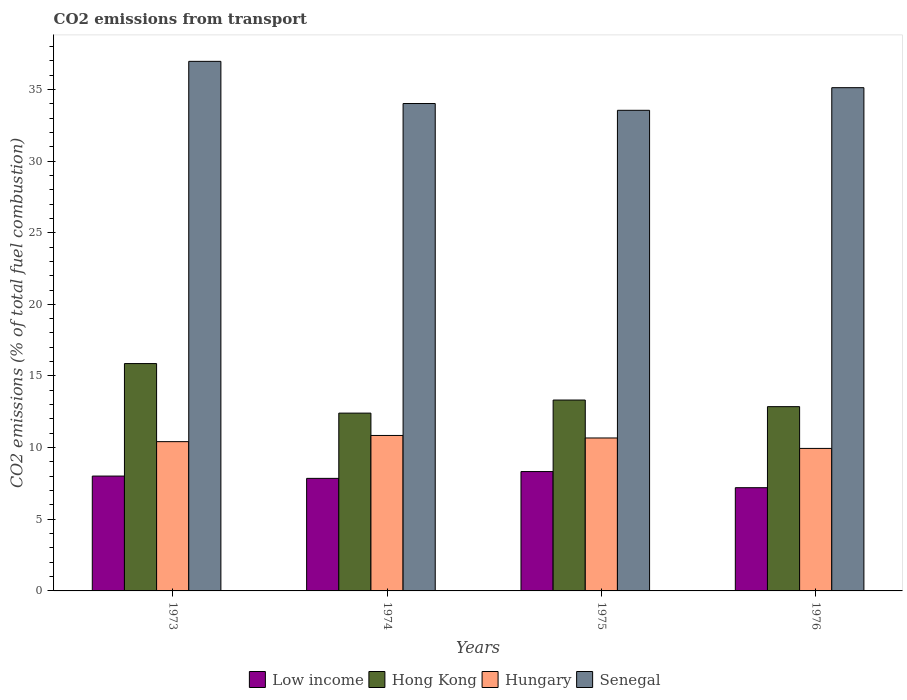How many groups of bars are there?
Your answer should be compact. 4. Are the number of bars per tick equal to the number of legend labels?
Your answer should be very brief. Yes. What is the label of the 4th group of bars from the left?
Your answer should be very brief. 1976. In how many cases, is the number of bars for a given year not equal to the number of legend labels?
Give a very brief answer. 0. What is the total CO2 emitted in Hong Kong in 1974?
Provide a short and direct response. 12.41. Across all years, what is the maximum total CO2 emitted in Hungary?
Offer a very short reply. 10.85. Across all years, what is the minimum total CO2 emitted in Hungary?
Your answer should be compact. 9.94. In which year was the total CO2 emitted in Hungary maximum?
Make the answer very short. 1974. In which year was the total CO2 emitted in Senegal minimum?
Ensure brevity in your answer.  1975. What is the total total CO2 emitted in Low income in the graph?
Keep it short and to the point. 31.4. What is the difference between the total CO2 emitted in Hong Kong in 1975 and that in 1976?
Your response must be concise. 0.46. What is the difference between the total CO2 emitted in Hong Kong in 1975 and the total CO2 emitted in Senegal in 1974?
Your answer should be compact. -20.69. What is the average total CO2 emitted in Senegal per year?
Provide a short and direct response. 34.91. In the year 1975, what is the difference between the total CO2 emitted in Hungary and total CO2 emitted in Senegal?
Ensure brevity in your answer.  -22.87. What is the ratio of the total CO2 emitted in Hungary in 1973 to that in 1976?
Provide a short and direct response. 1.05. Is the total CO2 emitted in Senegal in 1973 less than that in 1974?
Give a very brief answer. No. What is the difference between the highest and the second highest total CO2 emitted in Hong Kong?
Your response must be concise. 2.55. What is the difference between the highest and the lowest total CO2 emitted in Hungary?
Offer a very short reply. 0.9. In how many years, is the total CO2 emitted in Hungary greater than the average total CO2 emitted in Hungary taken over all years?
Ensure brevity in your answer.  2. Is the sum of the total CO2 emitted in Low income in 1974 and 1975 greater than the maximum total CO2 emitted in Hong Kong across all years?
Make the answer very short. Yes. What does the 4th bar from the left in 1973 represents?
Keep it short and to the point. Senegal. What does the 1st bar from the right in 1976 represents?
Offer a terse response. Senegal. Is it the case that in every year, the sum of the total CO2 emitted in Hong Kong and total CO2 emitted in Senegal is greater than the total CO2 emitted in Low income?
Offer a terse response. Yes. Are all the bars in the graph horizontal?
Give a very brief answer. No. How many years are there in the graph?
Provide a succinct answer. 4. Are the values on the major ticks of Y-axis written in scientific E-notation?
Make the answer very short. No. Where does the legend appear in the graph?
Provide a succinct answer. Bottom center. How are the legend labels stacked?
Keep it short and to the point. Horizontal. What is the title of the graph?
Your response must be concise. CO2 emissions from transport. Does "Philippines" appear as one of the legend labels in the graph?
Your response must be concise. No. What is the label or title of the X-axis?
Provide a short and direct response. Years. What is the label or title of the Y-axis?
Offer a terse response. CO2 emissions (% of total fuel combustion). What is the CO2 emissions (% of total fuel combustion) in Low income in 1973?
Provide a short and direct response. 8.01. What is the CO2 emissions (% of total fuel combustion) in Hong Kong in 1973?
Your answer should be compact. 15.87. What is the CO2 emissions (% of total fuel combustion) of Hungary in 1973?
Your answer should be compact. 10.42. What is the CO2 emissions (% of total fuel combustion) in Senegal in 1973?
Your answer should be very brief. 36.96. What is the CO2 emissions (% of total fuel combustion) in Low income in 1974?
Your response must be concise. 7.85. What is the CO2 emissions (% of total fuel combustion) of Hong Kong in 1974?
Your answer should be compact. 12.41. What is the CO2 emissions (% of total fuel combustion) of Hungary in 1974?
Offer a very short reply. 10.85. What is the CO2 emissions (% of total fuel combustion) of Senegal in 1974?
Your response must be concise. 34.01. What is the CO2 emissions (% of total fuel combustion) of Low income in 1975?
Your response must be concise. 8.33. What is the CO2 emissions (% of total fuel combustion) in Hong Kong in 1975?
Offer a very short reply. 13.32. What is the CO2 emissions (% of total fuel combustion) in Hungary in 1975?
Make the answer very short. 10.67. What is the CO2 emissions (% of total fuel combustion) of Senegal in 1975?
Offer a very short reply. 33.54. What is the CO2 emissions (% of total fuel combustion) in Low income in 1976?
Your answer should be compact. 7.2. What is the CO2 emissions (% of total fuel combustion) in Hong Kong in 1976?
Keep it short and to the point. 12.86. What is the CO2 emissions (% of total fuel combustion) in Hungary in 1976?
Provide a short and direct response. 9.94. What is the CO2 emissions (% of total fuel combustion) in Senegal in 1976?
Your answer should be very brief. 35.12. Across all years, what is the maximum CO2 emissions (% of total fuel combustion) in Low income?
Provide a succinct answer. 8.33. Across all years, what is the maximum CO2 emissions (% of total fuel combustion) in Hong Kong?
Give a very brief answer. 15.87. Across all years, what is the maximum CO2 emissions (% of total fuel combustion) in Hungary?
Keep it short and to the point. 10.85. Across all years, what is the maximum CO2 emissions (% of total fuel combustion) of Senegal?
Give a very brief answer. 36.96. Across all years, what is the minimum CO2 emissions (% of total fuel combustion) of Low income?
Give a very brief answer. 7.2. Across all years, what is the minimum CO2 emissions (% of total fuel combustion) of Hong Kong?
Make the answer very short. 12.41. Across all years, what is the minimum CO2 emissions (% of total fuel combustion) in Hungary?
Your answer should be compact. 9.94. Across all years, what is the minimum CO2 emissions (% of total fuel combustion) of Senegal?
Your response must be concise. 33.54. What is the total CO2 emissions (% of total fuel combustion) of Low income in the graph?
Offer a very short reply. 31.4. What is the total CO2 emissions (% of total fuel combustion) in Hong Kong in the graph?
Ensure brevity in your answer.  54.46. What is the total CO2 emissions (% of total fuel combustion) of Hungary in the graph?
Ensure brevity in your answer.  41.88. What is the total CO2 emissions (% of total fuel combustion) of Senegal in the graph?
Ensure brevity in your answer.  139.63. What is the difference between the CO2 emissions (% of total fuel combustion) in Low income in 1973 and that in 1974?
Make the answer very short. 0.16. What is the difference between the CO2 emissions (% of total fuel combustion) of Hong Kong in 1973 and that in 1974?
Your answer should be compact. 3.46. What is the difference between the CO2 emissions (% of total fuel combustion) in Hungary in 1973 and that in 1974?
Make the answer very short. -0.43. What is the difference between the CO2 emissions (% of total fuel combustion) of Senegal in 1973 and that in 1974?
Keep it short and to the point. 2.94. What is the difference between the CO2 emissions (% of total fuel combustion) in Low income in 1973 and that in 1975?
Ensure brevity in your answer.  -0.31. What is the difference between the CO2 emissions (% of total fuel combustion) in Hong Kong in 1973 and that in 1975?
Provide a succinct answer. 2.55. What is the difference between the CO2 emissions (% of total fuel combustion) of Hungary in 1973 and that in 1975?
Your answer should be very brief. -0.26. What is the difference between the CO2 emissions (% of total fuel combustion) of Senegal in 1973 and that in 1975?
Ensure brevity in your answer.  3.42. What is the difference between the CO2 emissions (% of total fuel combustion) in Low income in 1973 and that in 1976?
Provide a succinct answer. 0.81. What is the difference between the CO2 emissions (% of total fuel combustion) of Hong Kong in 1973 and that in 1976?
Give a very brief answer. 3.01. What is the difference between the CO2 emissions (% of total fuel combustion) in Hungary in 1973 and that in 1976?
Make the answer very short. 0.47. What is the difference between the CO2 emissions (% of total fuel combustion) in Senegal in 1973 and that in 1976?
Give a very brief answer. 1.84. What is the difference between the CO2 emissions (% of total fuel combustion) of Low income in 1974 and that in 1975?
Your answer should be very brief. -0.47. What is the difference between the CO2 emissions (% of total fuel combustion) in Hong Kong in 1974 and that in 1975?
Give a very brief answer. -0.91. What is the difference between the CO2 emissions (% of total fuel combustion) of Hungary in 1974 and that in 1975?
Your answer should be compact. 0.18. What is the difference between the CO2 emissions (% of total fuel combustion) in Senegal in 1974 and that in 1975?
Keep it short and to the point. 0.47. What is the difference between the CO2 emissions (% of total fuel combustion) in Low income in 1974 and that in 1976?
Provide a short and direct response. 0.65. What is the difference between the CO2 emissions (% of total fuel combustion) in Hong Kong in 1974 and that in 1976?
Keep it short and to the point. -0.45. What is the difference between the CO2 emissions (% of total fuel combustion) of Hungary in 1974 and that in 1976?
Give a very brief answer. 0.9. What is the difference between the CO2 emissions (% of total fuel combustion) in Senegal in 1974 and that in 1976?
Offer a very short reply. -1.11. What is the difference between the CO2 emissions (% of total fuel combustion) of Low income in 1975 and that in 1976?
Your answer should be compact. 1.13. What is the difference between the CO2 emissions (% of total fuel combustion) of Hong Kong in 1975 and that in 1976?
Your response must be concise. 0.46. What is the difference between the CO2 emissions (% of total fuel combustion) of Hungary in 1975 and that in 1976?
Keep it short and to the point. 0.73. What is the difference between the CO2 emissions (% of total fuel combustion) of Senegal in 1975 and that in 1976?
Your answer should be very brief. -1.58. What is the difference between the CO2 emissions (% of total fuel combustion) of Low income in 1973 and the CO2 emissions (% of total fuel combustion) of Hong Kong in 1974?
Your response must be concise. -4.39. What is the difference between the CO2 emissions (% of total fuel combustion) in Low income in 1973 and the CO2 emissions (% of total fuel combustion) in Hungary in 1974?
Your answer should be very brief. -2.83. What is the difference between the CO2 emissions (% of total fuel combustion) of Low income in 1973 and the CO2 emissions (% of total fuel combustion) of Senegal in 1974?
Offer a terse response. -26. What is the difference between the CO2 emissions (% of total fuel combustion) in Hong Kong in 1973 and the CO2 emissions (% of total fuel combustion) in Hungary in 1974?
Offer a terse response. 5.02. What is the difference between the CO2 emissions (% of total fuel combustion) in Hong Kong in 1973 and the CO2 emissions (% of total fuel combustion) in Senegal in 1974?
Your response must be concise. -18.15. What is the difference between the CO2 emissions (% of total fuel combustion) of Hungary in 1973 and the CO2 emissions (% of total fuel combustion) of Senegal in 1974?
Keep it short and to the point. -23.6. What is the difference between the CO2 emissions (% of total fuel combustion) in Low income in 1973 and the CO2 emissions (% of total fuel combustion) in Hong Kong in 1975?
Offer a very short reply. -5.31. What is the difference between the CO2 emissions (% of total fuel combustion) of Low income in 1973 and the CO2 emissions (% of total fuel combustion) of Hungary in 1975?
Your response must be concise. -2.66. What is the difference between the CO2 emissions (% of total fuel combustion) of Low income in 1973 and the CO2 emissions (% of total fuel combustion) of Senegal in 1975?
Your answer should be compact. -25.53. What is the difference between the CO2 emissions (% of total fuel combustion) in Hong Kong in 1973 and the CO2 emissions (% of total fuel combustion) in Hungary in 1975?
Provide a succinct answer. 5.19. What is the difference between the CO2 emissions (% of total fuel combustion) of Hong Kong in 1973 and the CO2 emissions (% of total fuel combustion) of Senegal in 1975?
Your response must be concise. -17.67. What is the difference between the CO2 emissions (% of total fuel combustion) in Hungary in 1973 and the CO2 emissions (% of total fuel combustion) in Senegal in 1975?
Ensure brevity in your answer.  -23.12. What is the difference between the CO2 emissions (% of total fuel combustion) in Low income in 1973 and the CO2 emissions (% of total fuel combustion) in Hong Kong in 1976?
Make the answer very short. -4.84. What is the difference between the CO2 emissions (% of total fuel combustion) of Low income in 1973 and the CO2 emissions (% of total fuel combustion) of Hungary in 1976?
Your answer should be compact. -1.93. What is the difference between the CO2 emissions (% of total fuel combustion) in Low income in 1973 and the CO2 emissions (% of total fuel combustion) in Senegal in 1976?
Your answer should be compact. -27.1. What is the difference between the CO2 emissions (% of total fuel combustion) of Hong Kong in 1973 and the CO2 emissions (% of total fuel combustion) of Hungary in 1976?
Give a very brief answer. 5.92. What is the difference between the CO2 emissions (% of total fuel combustion) in Hong Kong in 1973 and the CO2 emissions (% of total fuel combustion) in Senegal in 1976?
Offer a very short reply. -19.25. What is the difference between the CO2 emissions (% of total fuel combustion) in Hungary in 1973 and the CO2 emissions (% of total fuel combustion) in Senegal in 1976?
Your response must be concise. -24.7. What is the difference between the CO2 emissions (% of total fuel combustion) in Low income in 1974 and the CO2 emissions (% of total fuel combustion) in Hong Kong in 1975?
Make the answer very short. -5.47. What is the difference between the CO2 emissions (% of total fuel combustion) in Low income in 1974 and the CO2 emissions (% of total fuel combustion) in Hungary in 1975?
Make the answer very short. -2.82. What is the difference between the CO2 emissions (% of total fuel combustion) in Low income in 1974 and the CO2 emissions (% of total fuel combustion) in Senegal in 1975?
Your response must be concise. -25.69. What is the difference between the CO2 emissions (% of total fuel combustion) in Hong Kong in 1974 and the CO2 emissions (% of total fuel combustion) in Hungary in 1975?
Your answer should be very brief. 1.74. What is the difference between the CO2 emissions (% of total fuel combustion) of Hong Kong in 1974 and the CO2 emissions (% of total fuel combustion) of Senegal in 1975?
Offer a terse response. -21.13. What is the difference between the CO2 emissions (% of total fuel combustion) of Hungary in 1974 and the CO2 emissions (% of total fuel combustion) of Senegal in 1975?
Give a very brief answer. -22.69. What is the difference between the CO2 emissions (% of total fuel combustion) of Low income in 1974 and the CO2 emissions (% of total fuel combustion) of Hong Kong in 1976?
Your answer should be very brief. -5. What is the difference between the CO2 emissions (% of total fuel combustion) of Low income in 1974 and the CO2 emissions (% of total fuel combustion) of Hungary in 1976?
Ensure brevity in your answer.  -2.09. What is the difference between the CO2 emissions (% of total fuel combustion) in Low income in 1974 and the CO2 emissions (% of total fuel combustion) in Senegal in 1976?
Offer a very short reply. -27.26. What is the difference between the CO2 emissions (% of total fuel combustion) of Hong Kong in 1974 and the CO2 emissions (% of total fuel combustion) of Hungary in 1976?
Your answer should be very brief. 2.46. What is the difference between the CO2 emissions (% of total fuel combustion) of Hong Kong in 1974 and the CO2 emissions (% of total fuel combustion) of Senegal in 1976?
Make the answer very short. -22.71. What is the difference between the CO2 emissions (% of total fuel combustion) of Hungary in 1974 and the CO2 emissions (% of total fuel combustion) of Senegal in 1976?
Provide a succinct answer. -24.27. What is the difference between the CO2 emissions (% of total fuel combustion) in Low income in 1975 and the CO2 emissions (% of total fuel combustion) in Hong Kong in 1976?
Ensure brevity in your answer.  -4.53. What is the difference between the CO2 emissions (% of total fuel combustion) in Low income in 1975 and the CO2 emissions (% of total fuel combustion) in Hungary in 1976?
Provide a short and direct response. -1.62. What is the difference between the CO2 emissions (% of total fuel combustion) in Low income in 1975 and the CO2 emissions (% of total fuel combustion) in Senegal in 1976?
Provide a succinct answer. -26.79. What is the difference between the CO2 emissions (% of total fuel combustion) of Hong Kong in 1975 and the CO2 emissions (% of total fuel combustion) of Hungary in 1976?
Your answer should be compact. 3.38. What is the difference between the CO2 emissions (% of total fuel combustion) of Hong Kong in 1975 and the CO2 emissions (% of total fuel combustion) of Senegal in 1976?
Offer a very short reply. -21.8. What is the difference between the CO2 emissions (% of total fuel combustion) in Hungary in 1975 and the CO2 emissions (% of total fuel combustion) in Senegal in 1976?
Ensure brevity in your answer.  -24.45. What is the average CO2 emissions (% of total fuel combustion) of Low income per year?
Offer a terse response. 7.85. What is the average CO2 emissions (% of total fuel combustion) in Hong Kong per year?
Your answer should be compact. 13.61. What is the average CO2 emissions (% of total fuel combustion) in Hungary per year?
Your answer should be compact. 10.47. What is the average CO2 emissions (% of total fuel combustion) of Senegal per year?
Make the answer very short. 34.91. In the year 1973, what is the difference between the CO2 emissions (% of total fuel combustion) in Low income and CO2 emissions (% of total fuel combustion) in Hong Kong?
Ensure brevity in your answer.  -7.85. In the year 1973, what is the difference between the CO2 emissions (% of total fuel combustion) in Low income and CO2 emissions (% of total fuel combustion) in Hungary?
Make the answer very short. -2.4. In the year 1973, what is the difference between the CO2 emissions (% of total fuel combustion) in Low income and CO2 emissions (% of total fuel combustion) in Senegal?
Provide a short and direct response. -28.94. In the year 1973, what is the difference between the CO2 emissions (% of total fuel combustion) in Hong Kong and CO2 emissions (% of total fuel combustion) in Hungary?
Give a very brief answer. 5.45. In the year 1973, what is the difference between the CO2 emissions (% of total fuel combustion) in Hong Kong and CO2 emissions (% of total fuel combustion) in Senegal?
Your answer should be compact. -21.09. In the year 1973, what is the difference between the CO2 emissions (% of total fuel combustion) of Hungary and CO2 emissions (% of total fuel combustion) of Senegal?
Ensure brevity in your answer.  -26.54. In the year 1974, what is the difference between the CO2 emissions (% of total fuel combustion) of Low income and CO2 emissions (% of total fuel combustion) of Hong Kong?
Make the answer very short. -4.55. In the year 1974, what is the difference between the CO2 emissions (% of total fuel combustion) in Low income and CO2 emissions (% of total fuel combustion) in Hungary?
Offer a terse response. -2.99. In the year 1974, what is the difference between the CO2 emissions (% of total fuel combustion) of Low income and CO2 emissions (% of total fuel combustion) of Senegal?
Your answer should be very brief. -26.16. In the year 1974, what is the difference between the CO2 emissions (% of total fuel combustion) in Hong Kong and CO2 emissions (% of total fuel combustion) in Hungary?
Make the answer very short. 1.56. In the year 1974, what is the difference between the CO2 emissions (% of total fuel combustion) of Hong Kong and CO2 emissions (% of total fuel combustion) of Senegal?
Your answer should be compact. -21.6. In the year 1974, what is the difference between the CO2 emissions (% of total fuel combustion) in Hungary and CO2 emissions (% of total fuel combustion) in Senegal?
Provide a succinct answer. -23.16. In the year 1975, what is the difference between the CO2 emissions (% of total fuel combustion) in Low income and CO2 emissions (% of total fuel combustion) in Hong Kong?
Offer a terse response. -4.99. In the year 1975, what is the difference between the CO2 emissions (% of total fuel combustion) in Low income and CO2 emissions (% of total fuel combustion) in Hungary?
Offer a very short reply. -2.34. In the year 1975, what is the difference between the CO2 emissions (% of total fuel combustion) of Low income and CO2 emissions (% of total fuel combustion) of Senegal?
Make the answer very short. -25.21. In the year 1975, what is the difference between the CO2 emissions (% of total fuel combustion) in Hong Kong and CO2 emissions (% of total fuel combustion) in Hungary?
Make the answer very short. 2.65. In the year 1975, what is the difference between the CO2 emissions (% of total fuel combustion) of Hong Kong and CO2 emissions (% of total fuel combustion) of Senegal?
Provide a short and direct response. -20.22. In the year 1975, what is the difference between the CO2 emissions (% of total fuel combustion) of Hungary and CO2 emissions (% of total fuel combustion) of Senegal?
Offer a very short reply. -22.87. In the year 1976, what is the difference between the CO2 emissions (% of total fuel combustion) in Low income and CO2 emissions (% of total fuel combustion) in Hong Kong?
Offer a very short reply. -5.66. In the year 1976, what is the difference between the CO2 emissions (% of total fuel combustion) in Low income and CO2 emissions (% of total fuel combustion) in Hungary?
Keep it short and to the point. -2.74. In the year 1976, what is the difference between the CO2 emissions (% of total fuel combustion) in Low income and CO2 emissions (% of total fuel combustion) in Senegal?
Your response must be concise. -27.92. In the year 1976, what is the difference between the CO2 emissions (% of total fuel combustion) in Hong Kong and CO2 emissions (% of total fuel combustion) in Hungary?
Make the answer very short. 2.91. In the year 1976, what is the difference between the CO2 emissions (% of total fuel combustion) of Hong Kong and CO2 emissions (% of total fuel combustion) of Senegal?
Offer a terse response. -22.26. In the year 1976, what is the difference between the CO2 emissions (% of total fuel combustion) in Hungary and CO2 emissions (% of total fuel combustion) in Senegal?
Your response must be concise. -25.17. What is the ratio of the CO2 emissions (% of total fuel combustion) in Low income in 1973 to that in 1974?
Offer a very short reply. 1.02. What is the ratio of the CO2 emissions (% of total fuel combustion) of Hong Kong in 1973 to that in 1974?
Offer a very short reply. 1.28. What is the ratio of the CO2 emissions (% of total fuel combustion) of Hungary in 1973 to that in 1974?
Ensure brevity in your answer.  0.96. What is the ratio of the CO2 emissions (% of total fuel combustion) in Senegal in 1973 to that in 1974?
Offer a very short reply. 1.09. What is the ratio of the CO2 emissions (% of total fuel combustion) of Low income in 1973 to that in 1975?
Your answer should be very brief. 0.96. What is the ratio of the CO2 emissions (% of total fuel combustion) in Hong Kong in 1973 to that in 1975?
Your answer should be compact. 1.19. What is the ratio of the CO2 emissions (% of total fuel combustion) in Hungary in 1973 to that in 1975?
Your response must be concise. 0.98. What is the ratio of the CO2 emissions (% of total fuel combustion) of Senegal in 1973 to that in 1975?
Your answer should be compact. 1.1. What is the ratio of the CO2 emissions (% of total fuel combustion) of Low income in 1973 to that in 1976?
Make the answer very short. 1.11. What is the ratio of the CO2 emissions (% of total fuel combustion) of Hong Kong in 1973 to that in 1976?
Offer a terse response. 1.23. What is the ratio of the CO2 emissions (% of total fuel combustion) in Hungary in 1973 to that in 1976?
Give a very brief answer. 1.05. What is the ratio of the CO2 emissions (% of total fuel combustion) in Senegal in 1973 to that in 1976?
Provide a succinct answer. 1.05. What is the ratio of the CO2 emissions (% of total fuel combustion) in Low income in 1974 to that in 1975?
Keep it short and to the point. 0.94. What is the ratio of the CO2 emissions (% of total fuel combustion) of Hong Kong in 1974 to that in 1975?
Your answer should be compact. 0.93. What is the ratio of the CO2 emissions (% of total fuel combustion) in Hungary in 1974 to that in 1975?
Give a very brief answer. 1.02. What is the ratio of the CO2 emissions (% of total fuel combustion) in Senegal in 1974 to that in 1975?
Your answer should be very brief. 1.01. What is the ratio of the CO2 emissions (% of total fuel combustion) of Low income in 1974 to that in 1976?
Provide a succinct answer. 1.09. What is the ratio of the CO2 emissions (% of total fuel combustion) of Hungary in 1974 to that in 1976?
Keep it short and to the point. 1.09. What is the ratio of the CO2 emissions (% of total fuel combustion) of Senegal in 1974 to that in 1976?
Offer a terse response. 0.97. What is the ratio of the CO2 emissions (% of total fuel combustion) in Low income in 1975 to that in 1976?
Keep it short and to the point. 1.16. What is the ratio of the CO2 emissions (% of total fuel combustion) of Hong Kong in 1975 to that in 1976?
Offer a terse response. 1.04. What is the ratio of the CO2 emissions (% of total fuel combustion) in Hungary in 1975 to that in 1976?
Make the answer very short. 1.07. What is the ratio of the CO2 emissions (% of total fuel combustion) in Senegal in 1975 to that in 1976?
Provide a succinct answer. 0.95. What is the difference between the highest and the second highest CO2 emissions (% of total fuel combustion) in Low income?
Give a very brief answer. 0.31. What is the difference between the highest and the second highest CO2 emissions (% of total fuel combustion) of Hong Kong?
Your response must be concise. 2.55. What is the difference between the highest and the second highest CO2 emissions (% of total fuel combustion) of Hungary?
Offer a very short reply. 0.18. What is the difference between the highest and the second highest CO2 emissions (% of total fuel combustion) in Senegal?
Give a very brief answer. 1.84. What is the difference between the highest and the lowest CO2 emissions (% of total fuel combustion) of Low income?
Provide a short and direct response. 1.13. What is the difference between the highest and the lowest CO2 emissions (% of total fuel combustion) in Hong Kong?
Give a very brief answer. 3.46. What is the difference between the highest and the lowest CO2 emissions (% of total fuel combustion) of Hungary?
Make the answer very short. 0.9. What is the difference between the highest and the lowest CO2 emissions (% of total fuel combustion) in Senegal?
Your answer should be very brief. 3.42. 